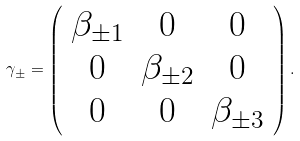Convert formula to latex. <formula><loc_0><loc_0><loc_500><loc_500>\gamma _ { \pm } = \left ( \begin{array} { c c c } { { \beta _ { \pm 1 } } } & { 0 } & { 0 } \\ { 0 } & { { \beta _ { \pm 2 } } } & { 0 } \\ { 0 } & { 0 } & { { \beta _ { \pm 3 } } } \end{array} \right ) .</formula> 